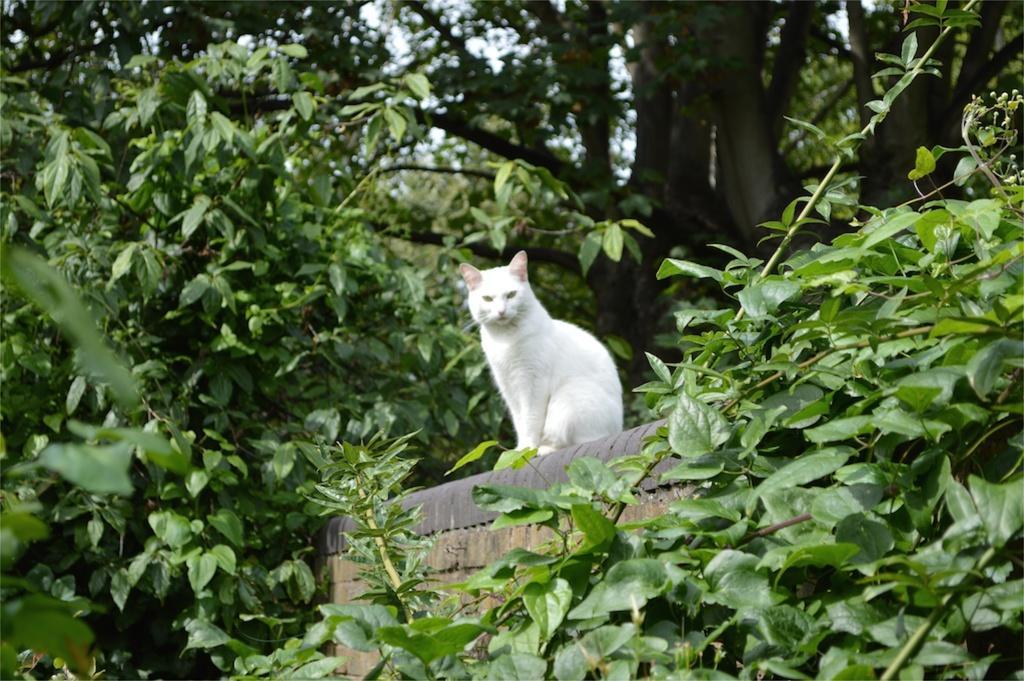Can you describe this image briefly? Here in this picture we can see a white colored cat present on the wall over there and we can see trees and plants present all over there. 